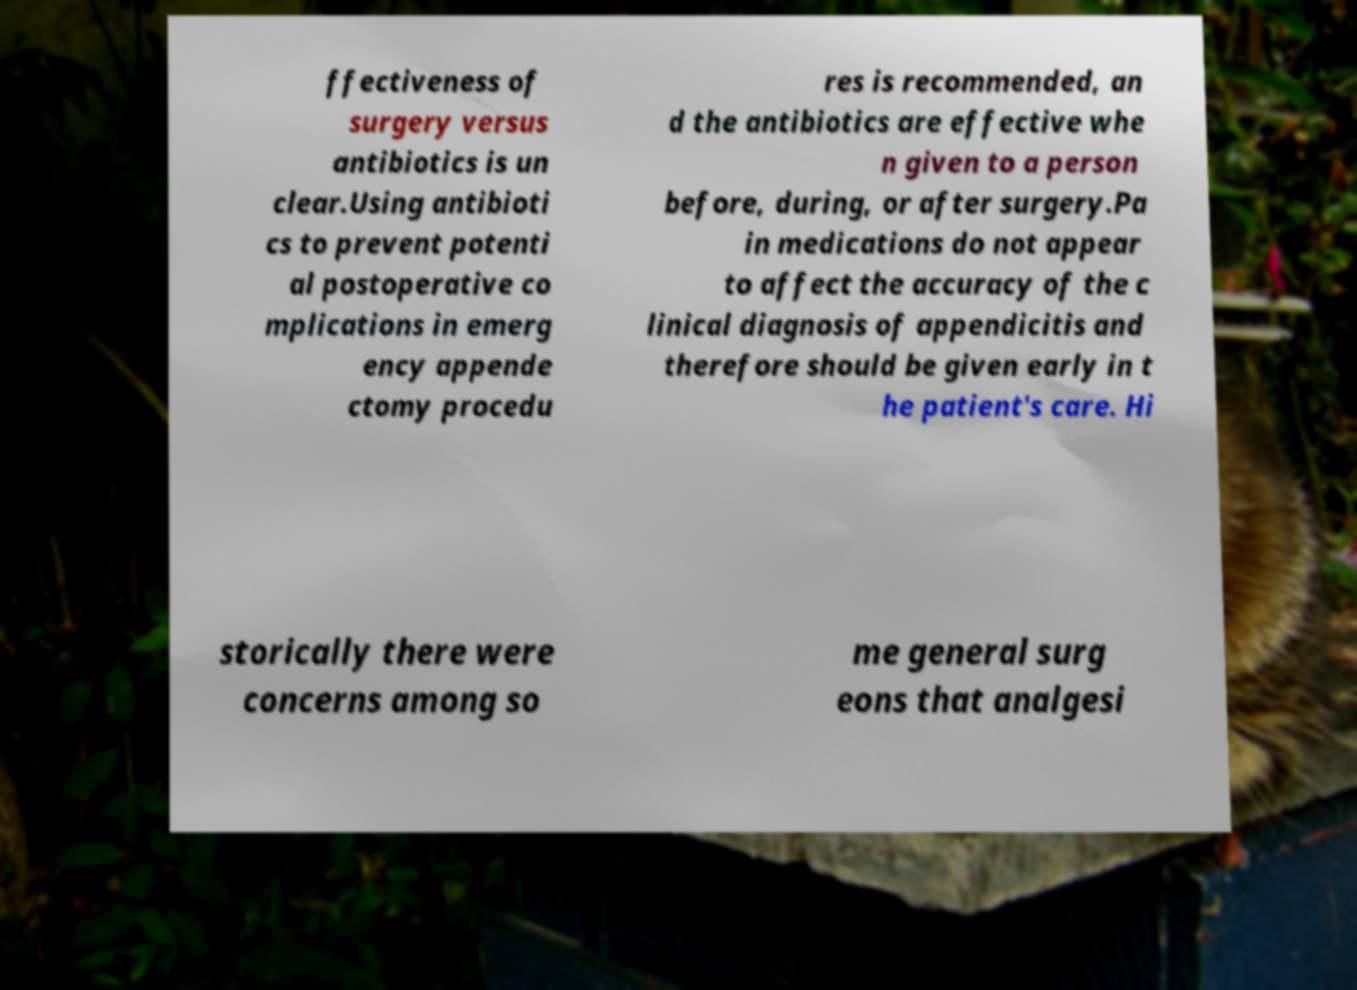Can you accurately transcribe the text from the provided image for me? ffectiveness of surgery versus antibiotics is un clear.Using antibioti cs to prevent potenti al postoperative co mplications in emerg ency appende ctomy procedu res is recommended, an d the antibiotics are effective whe n given to a person before, during, or after surgery.Pa in medications do not appear to affect the accuracy of the c linical diagnosis of appendicitis and therefore should be given early in t he patient's care. Hi storically there were concerns among so me general surg eons that analgesi 